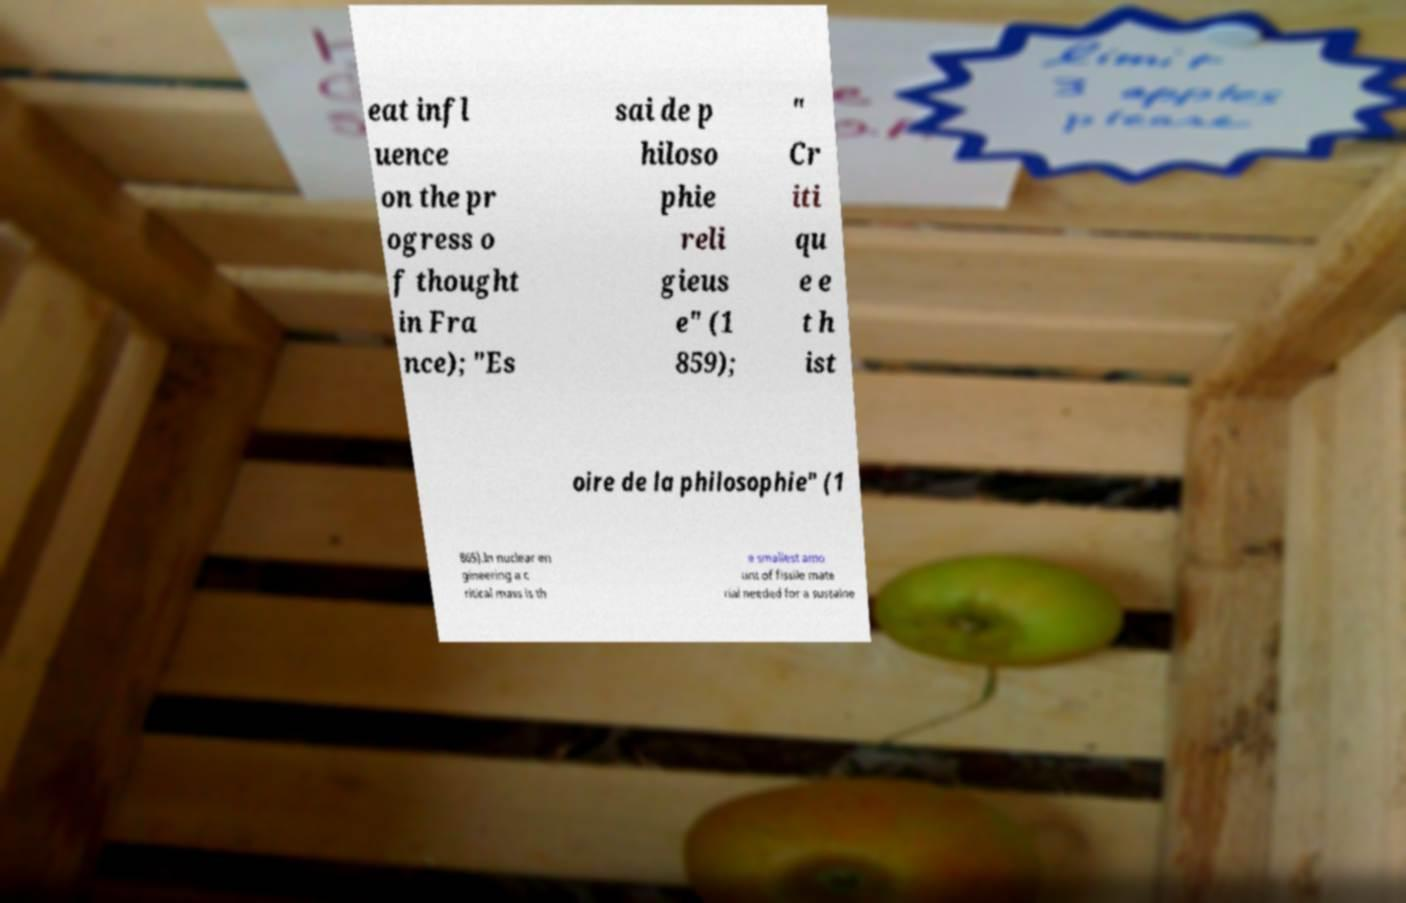Please identify and transcribe the text found in this image. eat infl uence on the pr ogress o f thought in Fra nce); "Es sai de p hiloso phie reli gieus e" (1 859); " Cr iti qu e e t h ist oire de la philosophie" (1 865).In nuclear en gineering a c ritical mass is th e smallest amo unt of fissile mate rial needed for a sustaine 